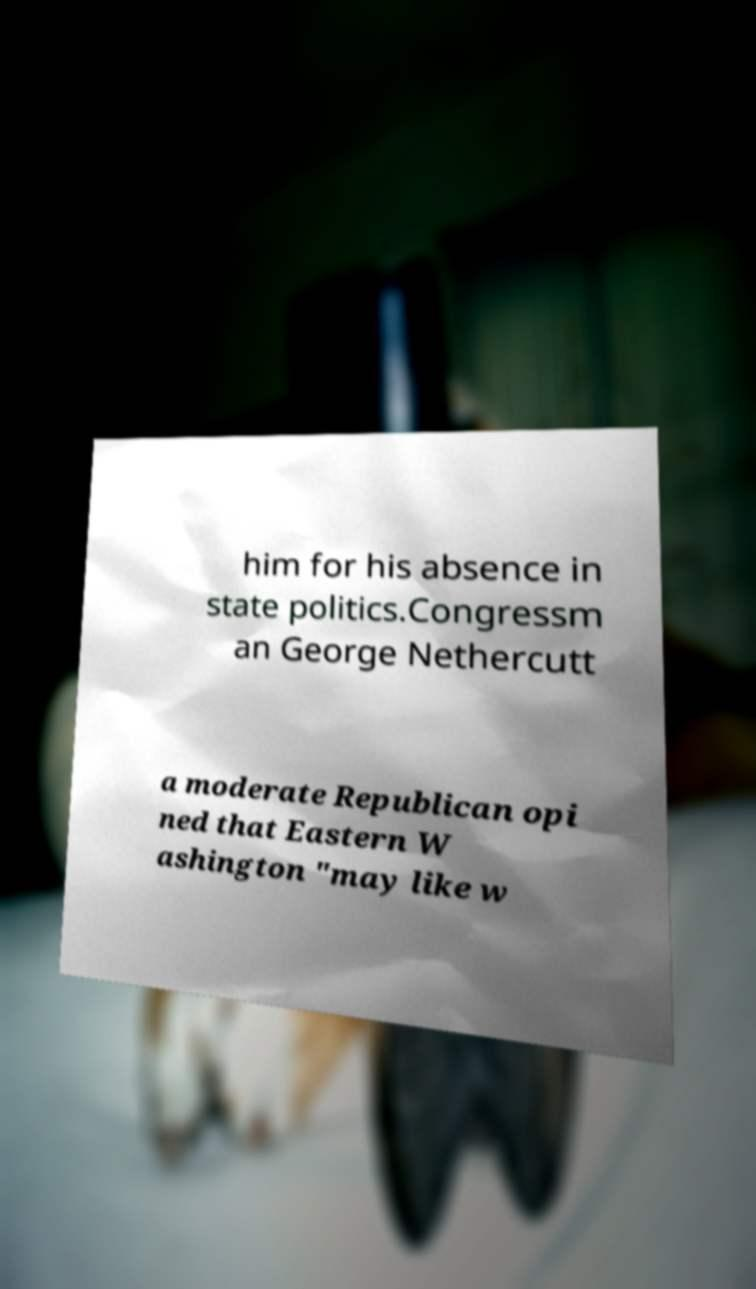Please identify and transcribe the text found in this image. him for his absence in state politics.Congressm an George Nethercutt a moderate Republican opi ned that Eastern W ashington "may like w 